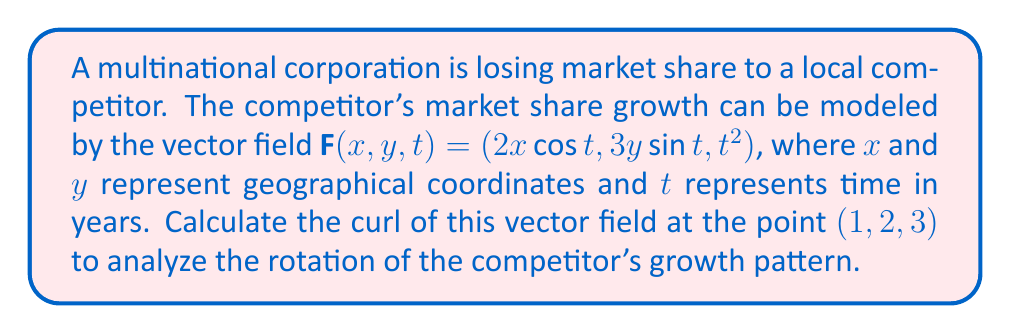Help me with this question. To analyze the rotation of the competitor's growth pattern, we need to calculate the curl of the given vector field. The curl of a vector field $\mathbf{F}(x,y,z) = (F_x, F_y, F_z)$ is defined as:

$$\text{curl } \mathbf{F} = \nabla \times \mathbf{F} = \left(\frac{\partial F_z}{\partial y} - \frac{\partial F_y}{\partial z}\right)\mathbf{i} + \left(\frac{\partial F_x}{\partial z} - \frac{\partial F_z}{\partial x}\right)\mathbf{j} + \left(\frac{\partial F_y}{\partial x} - \frac{\partial F_x}{\partial y}\right)\mathbf{k}$$

Given vector field: $\mathbf{F}(x,y,t) = (2x\cos t, 3y\sin t, t^2)$

Step 1: Identify the components
$F_x = 2x\cos t$
$F_y = 3y\sin t$
$F_z = t^2$

Step 2: Calculate the partial derivatives

$\frac{\partial F_z}{\partial y} = 0$
$\frac{\partial F_y}{\partial t} = 3y\cos t$
$\frac{\partial F_x}{\partial t} = -2x\sin t$
$\frac{\partial F_z}{\partial x} = 0$
$\frac{\partial F_y}{\partial x} = 0$
$\frac{\partial F_x}{\partial y} = 0$

Step 3: Apply the curl formula

$$\text{curl } \mathbf{F} = (0 - 3y\cos t)\mathbf{i} + (-2x\sin t - 0)\mathbf{j} + (0 - 0)\mathbf{k}$$

$$\text{curl } \mathbf{F} = (-3y\cos t)\mathbf{i} + (-2x\sin t)\mathbf{j} + 0\mathbf{k}$$

Step 4: Evaluate at the point (1,2,3)

$$\text{curl } \mathbf{F}(1,2,3) = (-6\cos 3)\mathbf{i} + (-2\sin 3)\mathbf{j} + 0\mathbf{k}$$

This is the final result of the curl calculation, representing the rotation of the competitor's growth pattern at the given point.
Answer: $(-6\cos 3)\mathbf{i} + (-2\sin 3)\mathbf{j} + 0\mathbf{k}$ 